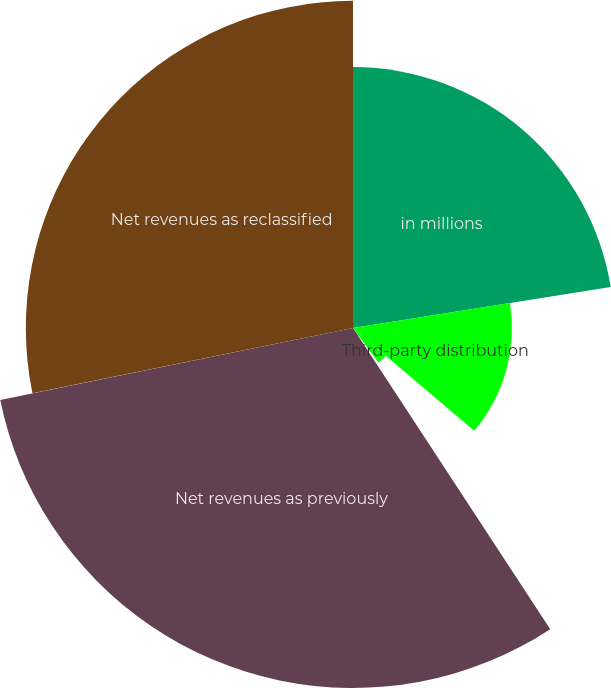Convert chart to OTSL. <chart><loc_0><loc_0><loc_500><loc_500><pie_chart><fcel>in millions<fcel>Third-party distribution<fcel>Reclassification<fcel>Marketing expenses as<fcel>Net revenues as previously<fcel>Net revenues as reclassified<nl><fcel>22.49%<fcel>13.7%<fcel>3.7%<fcel>0.88%<fcel>31.03%<fcel>28.2%<nl></chart> 